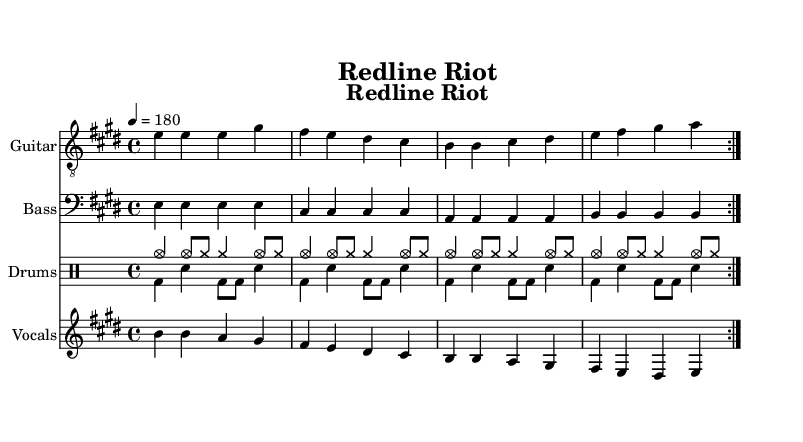What is the key signature of this music? The key signature is shown at the beginning of the staff and indicates that there are four sharps (F#, C#, G#, D#). This means it is in the key of E major.
Answer: E major What is the time signature of this music? The time signature is located after the key signature in the beginning of the staff; it is displayed as 4/4, indicating four beats per measure and a quarter note gets one beat.
Answer: 4/4 What is the tempo marking for this piece? The tempo marking is notated above the staff and indicates the pace of the music; it is specified as 4 = 180, meaning 180 beats per minute.
Answer: 180 How many measures are in the repeated section? The repeated section consists of one set of measures that is marked to repeat twice, and each complete cycle contains four measures. Since there are two cycles, the total is eight measures.
Answer: 8 Which instrument plays the main melody? The main melody is typically found in the vocals staff, which shows the melody alongside the lyrics, indicating that vocals carry the primary melodic line.
Answer: Vocals What is the dynamic style indicated for the drums? The drumming pattern is indicated by "cymc" and "bd," which refer to cymbals and bass drum sounds, respectively, typical in punk music where energy is key for driving rhythms.
Answer: High-energy What do the lyrics of the song suggest about its theme? The lyrics tell a story of excitement and power, mentioning "engines roar" and "punk rock thunder," which are metaphors for high-speed racing that parallels the energy of punk rock music.
Answer: Racing and excitement 